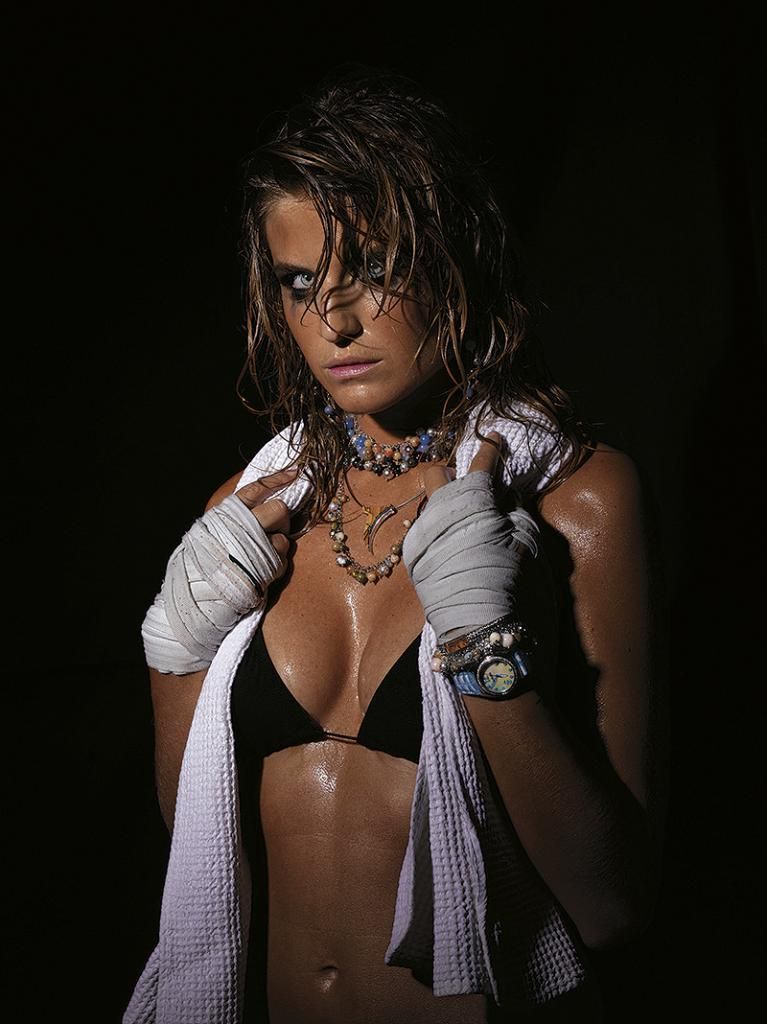Who is present in the image? There is a woman in the image. What can be observed about the background of the image? The background of the image is dark. What type of pie is being served on the table in the image? There is no table or pie present in the image; it only features a woman and a dark background. 